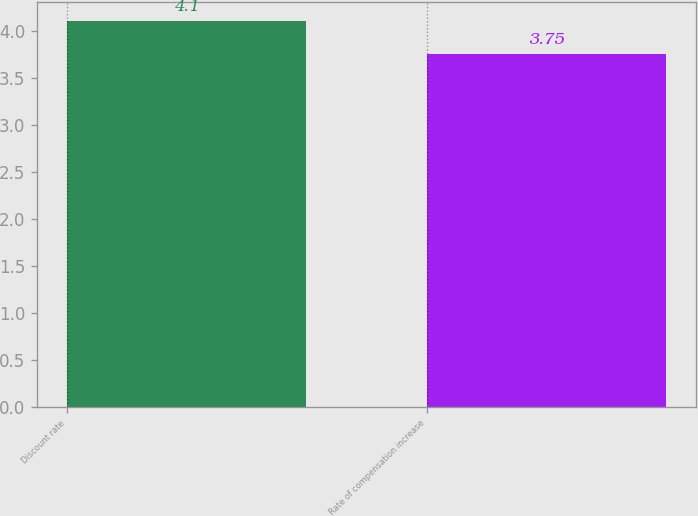Convert chart. <chart><loc_0><loc_0><loc_500><loc_500><bar_chart><fcel>Discount rate<fcel>Rate of compensation increase<nl><fcel>4.1<fcel>3.75<nl></chart> 